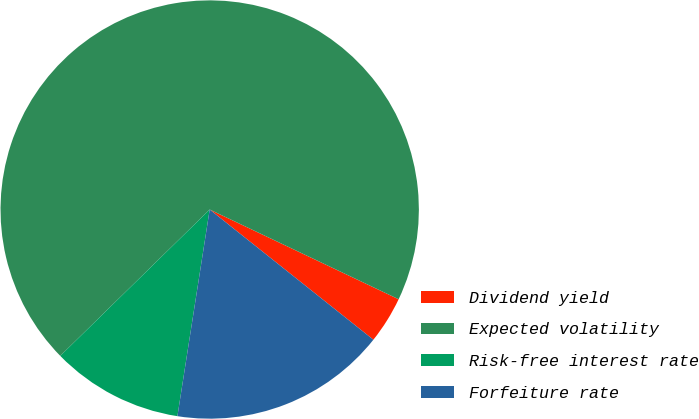<chart> <loc_0><loc_0><loc_500><loc_500><pie_chart><fcel>Dividend yield<fcel>Expected volatility<fcel>Risk-free interest rate<fcel>Forfeiture rate<nl><fcel>3.64%<fcel>69.39%<fcel>10.2%<fcel>16.77%<nl></chart> 